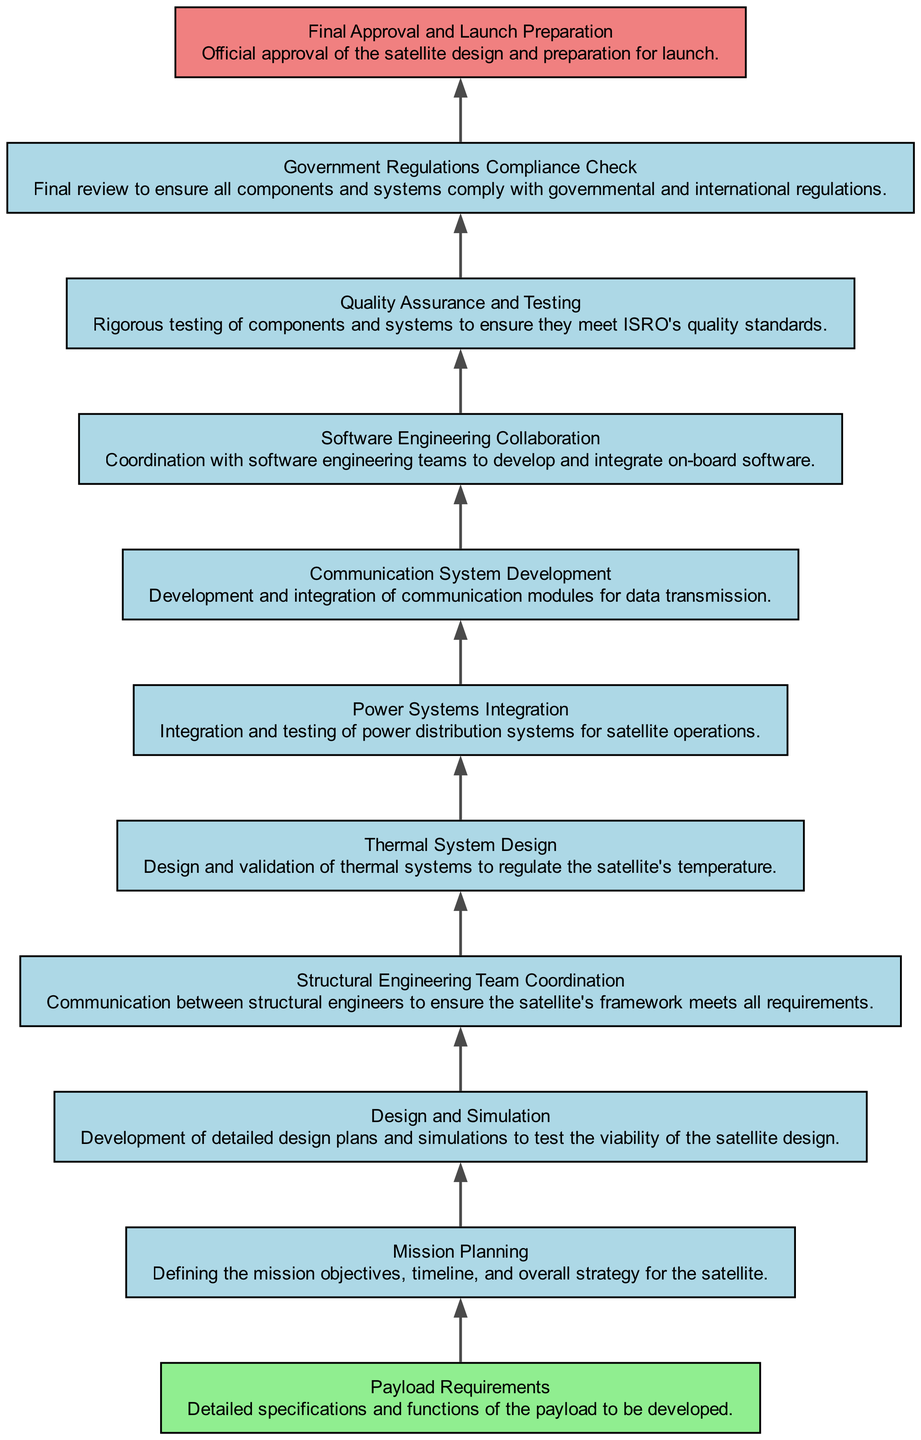What is the starting point of the flow chart? The flow chart begins with the node labeled "Payload Requirements," which is located at the bottom of the diagram, indicating the initial step in the inter-departmental coordination process for satellite development.
Answer: Payload Requirements How many nodes are present in the diagram? By counting each individual element represented in the diagram, there are a total of 11 nodes that describe various steps in the process of satellite development.
Answer: 11 What is the last step before the launch preparation? The final step before the "Final Approval and Launch Preparation" is the "Government Regulations Compliance Check," as it is directly above this node in the flow chart.
Answer: Government Regulations Compliance Check Which team coordinates with the software engineering teams? The "Software Engineering Collaboration" node indicates the coordination with software engineering teams to develop and integrate on-board software, reflecting the collaborative aspect of satellite development.
Answer: Software Engineering Collaboration What is the main focus of the "Quality Assurance and Testing" step? The purpose of this step is to rigorously test components and systems, ensuring they meet ISRO's quality standards before moving forward in the development process.
Answer: Testing components and systems What is the relationship between "Structural Engineering Team Coordination" and "Thermal System Design"? "Thermal System Design" follows "Structural Engineering Team Coordination," meaning that structural engineering discussions impact how the thermal systems will be designed and integrated into the satellite framework.
Answer: Sequential relationship What is the primary goal of the "Mission Planning" phase? The primary goal of "Mission Planning" is to define the mission objectives, timeline, and overall strategy for the satellite, which sets the foundation for all subsequent steps in development.
Answer: Define mission objectives Which stage requires validation related to temperature regulation? The "Thermal System Design" stage requires validation to ensure that the systems developed can effectively regulate the satellite's temperature, which is crucial for its operational success.
Answer: Thermal System Design How does "Power Systems Integration" relate to satellite operations? "Power Systems Integration" is crucial for the functionality of the satellite, as it comprises the integration and testing of power distribution systems that enable all operational aspects of the satellite.
Answer: Power distribution systems 